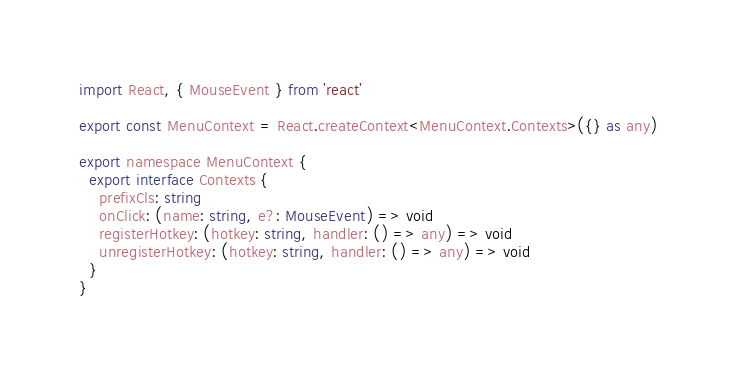Convert code to text. <code><loc_0><loc_0><loc_500><loc_500><_TypeScript_>import React, { MouseEvent } from 'react'

export const MenuContext = React.createContext<MenuContext.Contexts>({} as any)

export namespace MenuContext {
  export interface Contexts {
    prefixCls: string
    onClick: (name: string, e?: MouseEvent) => void
    registerHotkey: (hotkey: string, handler: () => any) => void
    unregisterHotkey: (hotkey: string, handler: () => any) => void
  }
}
</code> 